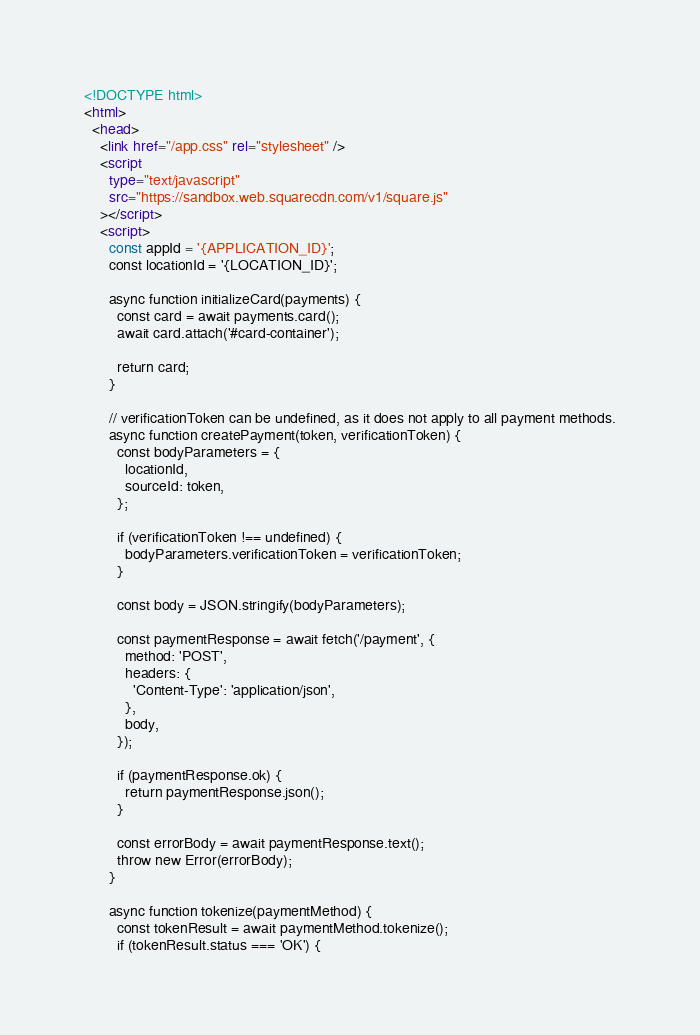<code> <loc_0><loc_0><loc_500><loc_500><_HTML_><!DOCTYPE html>
<html>
  <head>
    <link href="/app.css" rel="stylesheet" />
    <script
      type="text/javascript"
      src="https://sandbox.web.squarecdn.com/v1/square.js"
    ></script>
    <script>
      const appId = '{APPLICATION_ID}';
      const locationId = '{LOCATION_ID}';

      async function initializeCard(payments) {
        const card = await payments.card();
        await card.attach('#card-container');

        return card;
      }

      // verificationToken can be undefined, as it does not apply to all payment methods.
      async function createPayment(token, verificationToken) {
        const bodyParameters = {
          locationId,
          sourceId: token,
        };

        if (verificationToken !== undefined) {
          bodyParameters.verificationToken = verificationToken;
        }

        const body = JSON.stringify(bodyParameters);

        const paymentResponse = await fetch('/payment', {
          method: 'POST',
          headers: {
            'Content-Type': 'application/json',
          },
          body,
        });

        if (paymentResponse.ok) {
          return paymentResponse.json();
        }

        const errorBody = await paymentResponse.text();
        throw new Error(errorBody);
      }

      async function tokenize(paymentMethod) {
        const tokenResult = await paymentMethod.tokenize();
        if (tokenResult.status === 'OK') {</code> 